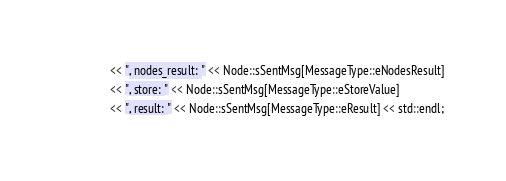Convert code to text. <code><loc_0><loc_0><loc_500><loc_500><_C++_>                << ", nodes_result: " << Node::sSentMsg[MessageType::eNodesResult]
                << ", store: " << Node::sSentMsg[MessageType::eStoreValue]
                << ", result: " << Node::sSentMsg[MessageType::eResult] << std::endl;
</code> 